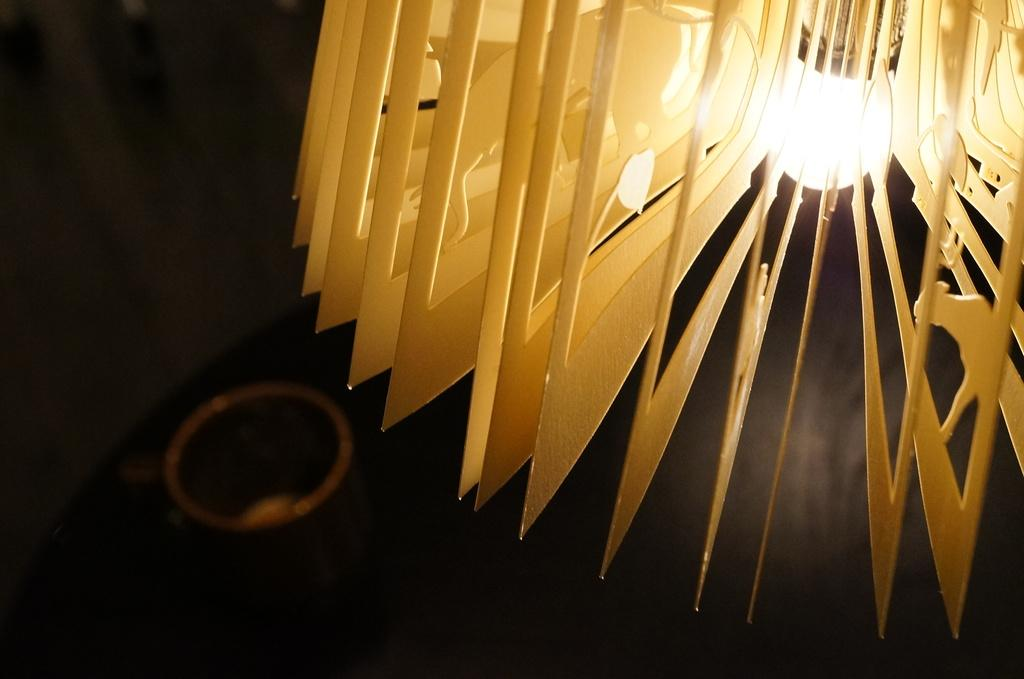What is the main subject of the image? The main subject of the image is a light with frames. Can you describe the background of the image? The background of the image is blurred. Are there any specific colors mentioned in the image? Yes, there are objects in black color in the image. How many boys are playing in the image? There are no boys present in the image; it features a light with frames and a blurred background. What type of memory is being stored in the image? The image does not depict any memory storage devices or processes. 